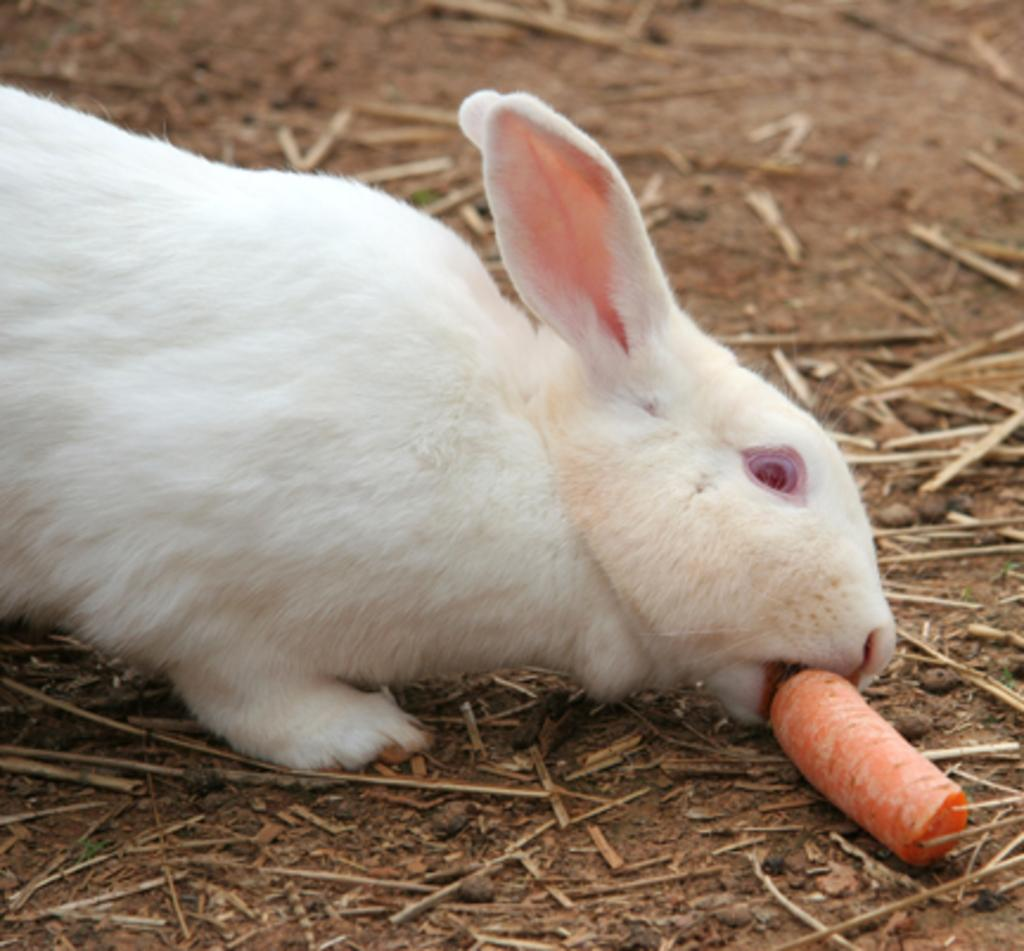What animal can be seen in the picture? There is a rabbit in the picture. What is the rabbit doing in the picture? The rabbit is eating a carrot in the picture. What type of vegetation is present in the picture? There is dried grass in the picture. What color is the milk being poured by the rabbit in the picture? There is no milk present in the image, and the rabbit is not pouring anything. 